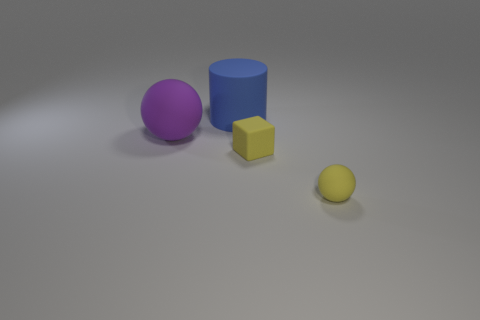There is a large thing right of the matte sphere left of the large matte thing that is behind the big purple rubber ball; what is its material?
Offer a terse response. Rubber. Are there any large blue objects made of the same material as the tiny yellow block?
Your answer should be compact. Yes. Is the material of the purple sphere the same as the blue object?
Offer a very short reply. Yes. How many cubes are either yellow matte objects or large things?
Make the answer very short. 1. What is the color of the big ball that is made of the same material as the big cylinder?
Make the answer very short. Purple. Are there fewer gray rubber cylinders than yellow rubber objects?
Your answer should be very brief. Yes. There is a thing that is behind the large matte ball; is it the same shape as the yellow matte object that is in front of the yellow block?
Offer a terse response. No. How many objects are small gray shiny balls or big blue objects?
Keep it short and to the point. 1. What color is the thing that is the same size as the purple ball?
Offer a terse response. Blue. How many small matte objects are left of the sphere to the right of the big rubber ball?
Provide a succinct answer. 1. 